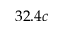<formula> <loc_0><loc_0><loc_500><loc_500>3 2 . 4 c</formula> 